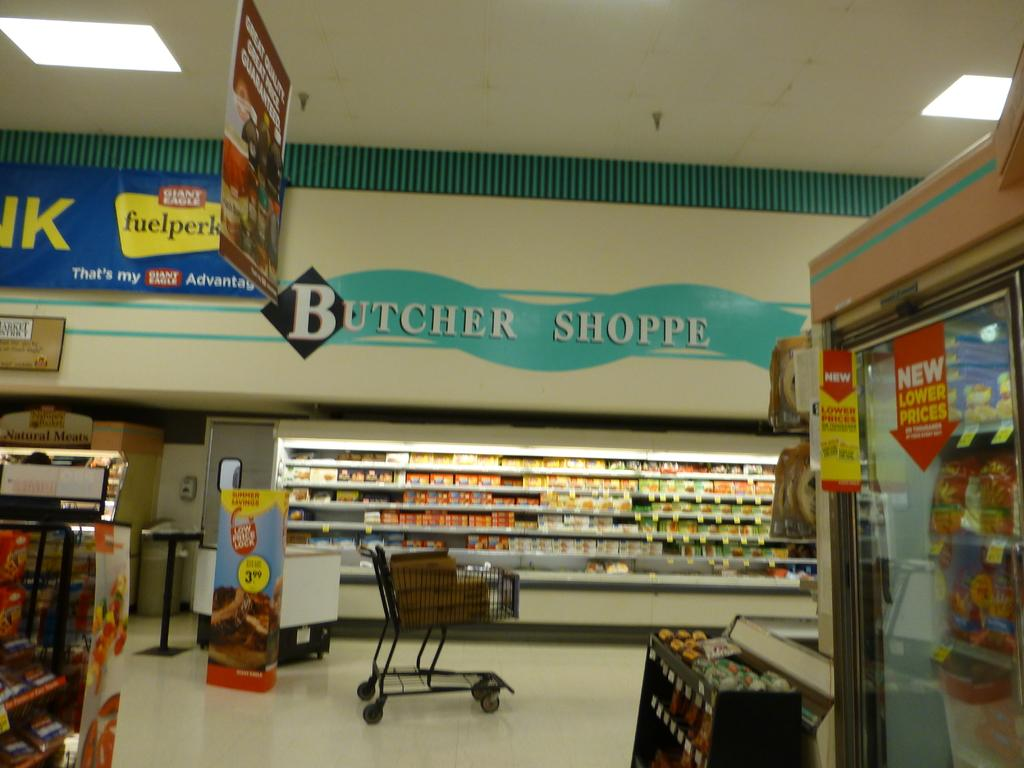<image>
Summarize the visual content of the image. Many varities of cold cuts populate the Butcher Shoppe section of a market. 